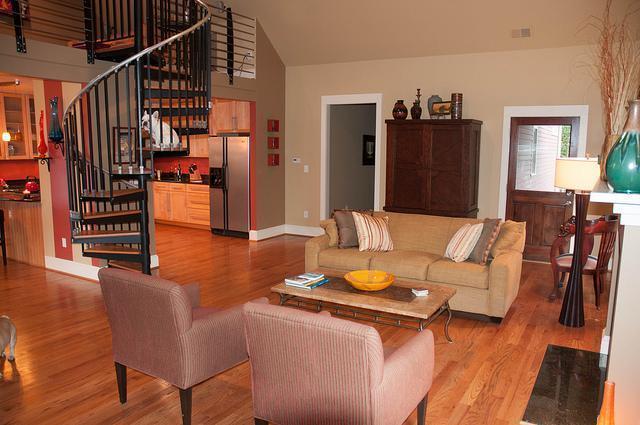What gives the square items on the couch their shape?
Make your selection and explain in format: 'Answer: answer
Rationale: rationale.'
Options: Stuffing, glass, plastic, styrofoam. Answer: stuffing.
Rationale: The chairs are full of stuffing. 